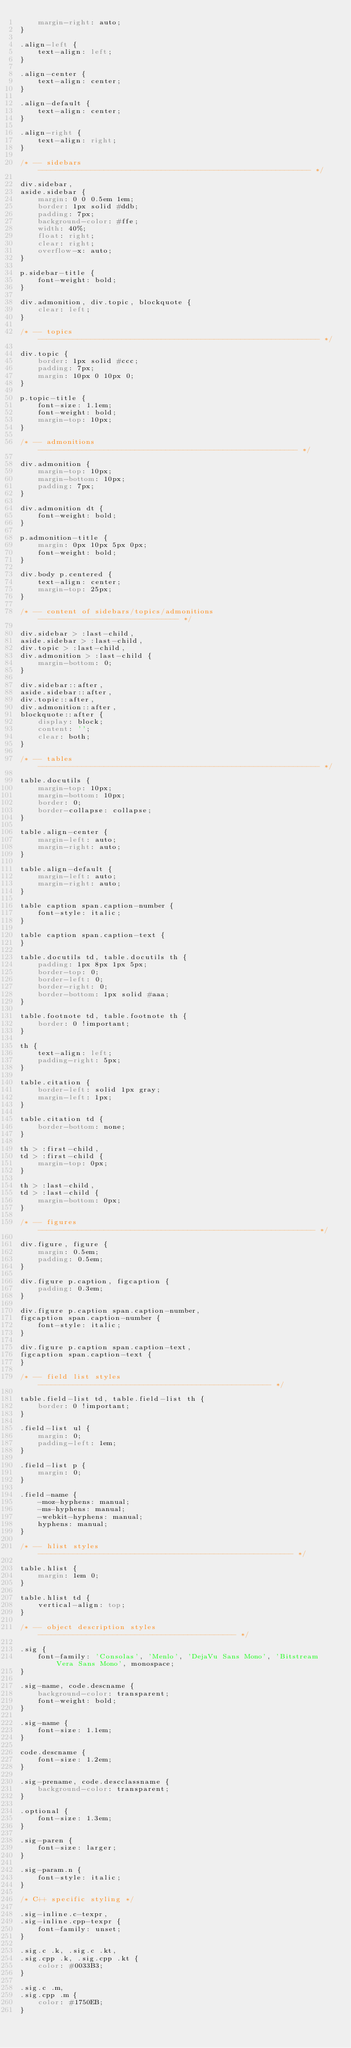<code> <loc_0><loc_0><loc_500><loc_500><_CSS_>    margin-right: auto;
}

.align-left {
    text-align: left;
}

.align-center {
    text-align: center;
}

.align-default {
    text-align: center;
}

.align-right {
    text-align: right;
}

/* -- sidebars -------------------------------------------------------------- */

div.sidebar,
aside.sidebar {
    margin: 0 0 0.5em 1em;
    border: 1px solid #ddb;
    padding: 7px;
    background-color: #ffe;
    width: 40%;
    float: right;
    clear: right;
    overflow-x: auto;
}

p.sidebar-title {
    font-weight: bold;
}

div.admonition, div.topic, blockquote {
    clear: left;
}

/* -- topics ---------------------------------------------------------------- */

div.topic {
    border: 1px solid #ccc;
    padding: 7px;
    margin: 10px 0 10px 0;
}

p.topic-title {
    font-size: 1.1em;
    font-weight: bold;
    margin-top: 10px;
}

/* -- admonitions ----------------------------------------------------------- */

div.admonition {
    margin-top: 10px;
    margin-bottom: 10px;
    padding: 7px;
}

div.admonition dt {
    font-weight: bold;
}

p.admonition-title {
    margin: 0px 10px 5px 0px;
    font-weight: bold;
}

div.body p.centered {
    text-align: center;
    margin-top: 25px;
}

/* -- content of sidebars/topics/admonitions -------------------------------- */

div.sidebar > :last-child,
aside.sidebar > :last-child,
div.topic > :last-child,
div.admonition > :last-child {
    margin-bottom: 0;
}

div.sidebar::after,
aside.sidebar::after,
div.topic::after,
div.admonition::after,
blockquote::after {
    display: block;
    content: '';
    clear: both;
}

/* -- tables ---------------------------------------------------------------- */

table.docutils {
    margin-top: 10px;
    margin-bottom: 10px;
    border: 0;
    border-collapse: collapse;
}

table.align-center {
    margin-left: auto;
    margin-right: auto;
}

table.align-default {
    margin-left: auto;
    margin-right: auto;
}

table caption span.caption-number {
    font-style: italic;
}

table caption span.caption-text {
}

table.docutils td, table.docutils th {
    padding: 1px 8px 1px 5px;
    border-top: 0;
    border-left: 0;
    border-right: 0;
    border-bottom: 1px solid #aaa;
}

table.footnote td, table.footnote th {
    border: 0 !important;
}

th {
    text-align: left;
    padding-right: 5px;
}

table.citation {
    border-left: solid 1px gray;
    margin-left: 1px;
}

table.citation td {
    border-bottom: none;
}

th > :first-child,
td > :first-child {
    margin-top: 0px;
}

th > :last-child,
td > :last-child {
    margin-bottom: 0px;
}

/* -- figures --------------------------------------------------------------- */

div.figure, figure {
    margin: 0.5em;
    padding: 0.5em;
}

div.figure p.caption, figcaption {
    padding: 0.3em;
}

div.figure p.caption span.caption-number,
figcaption span.caption-number {
    font-style: italic;
}

div.figure p.caption span.caption-text,
figcaption span.caption-text {
}

/* -- field list styles ----------------------------------------------------- */

table.field-list td, table.field-list th {
    border: 0 !important;
}

.field-list ul {
    margin: 0;
    padding-left: 1em;
}

.field-list p {
    margin: 0;
}

.field-name {
    -moz-hyphens: manual;
    -ms-hyphens: manual;
    -webkit-hyphens: manual;
    hyphens: manual;
}

/* -- hlist styles ---------------------------------------------------------- */

table.hlist {
    margin: 1em 0;
}

table.hlist td {
    vertical-align: top;
}

/* -- object description styles --------------------------------------------- */

.sig {
    font-family: 'Consolas', 'Menlo', 'DejaVu Sans Mono', 'Bitstream Vera Sans Mono', monospace;
}

.sig-name, code.descname {
    background-color: transparent;
    font-weight: bold;
}

.sig-name {
    font-size: 1.1em;
}

code.descname {
    font-size: 1.2em;
}

.sig-prename, code.descclassname {
    background-color: transparent;
}

.optional {
    font-size: 1.3em;
}

.sig-paren {
    font-size: larger;
}

.sig-param.n {
    font-style: italic;
}

/* C++ specific styling */

.sig-inline.c-texpr,
.sig-inline.cpp-texpr {
    font-family: unset;
}

.sig.c .k, .sig.c .kt,
.sig.cpp .k, .sig.cpp .kt {
    color: #0033B3;
}

.sig.c .m,
.sig.cpp .m {
    color: #1750EB;
}
</code> 